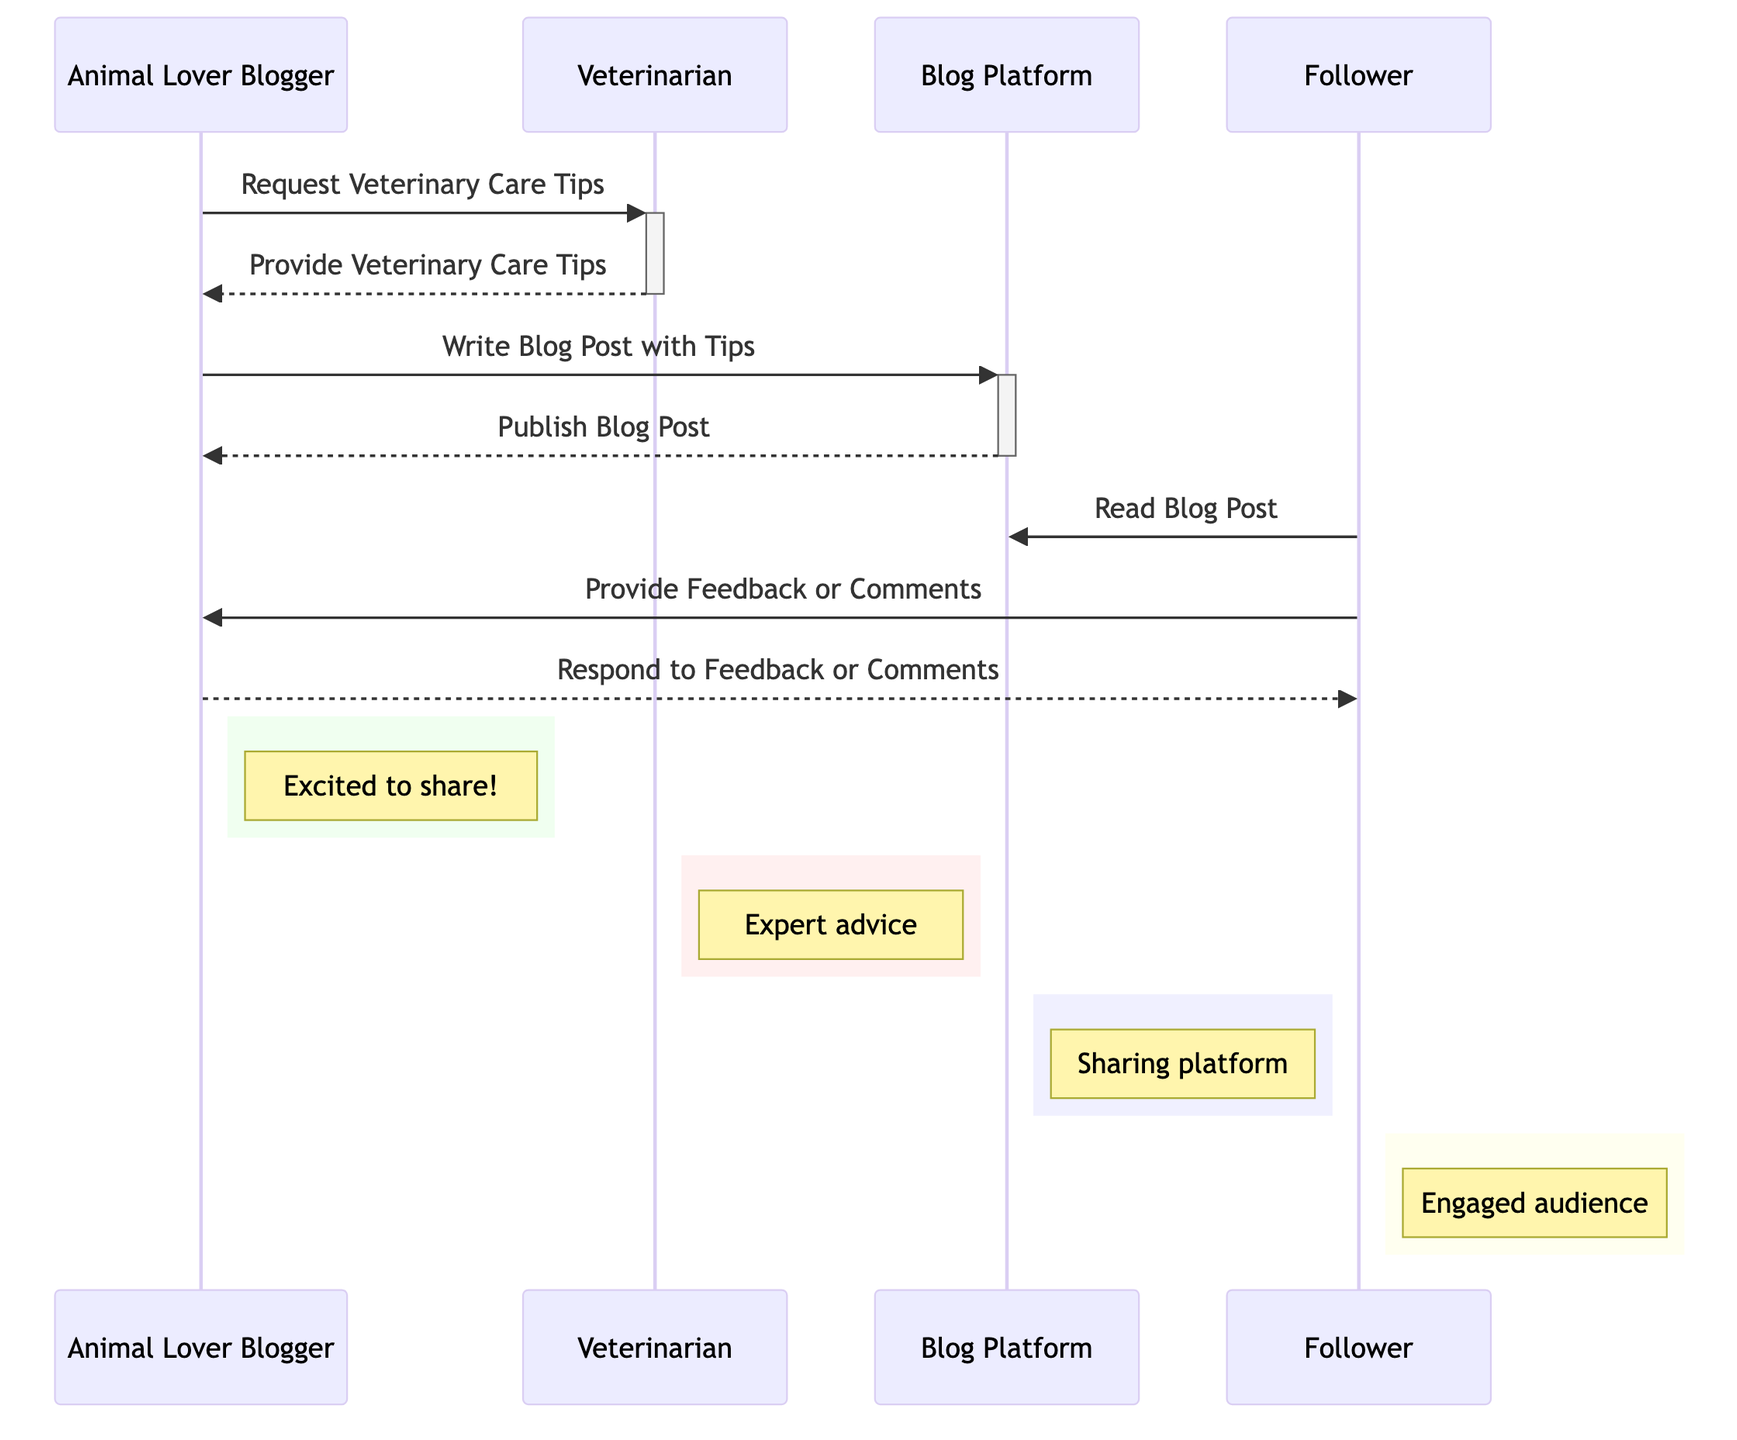What is the first action in the sequence? The first action in the sequence diagram is initiated by the Animal Lover Blogger requesting veterinary care tips from the Veterinarian.
Answer: Request Veterinary Care Tips How many users are represented in the diagram? There are three users represented in the diagram: the Animal Lover Blogger, Veterinarian, and Follower.
Answer: Three users What message does the Veterinarian send to the Animal Lover Blogger? The Veterinarian provides veterinary care tips in response to the Animal Lover Blogger's request.
Answer: Provide Veterinary Care Tips Which entity publishes the blog post? The Blog Platform is responsible for publishing the blog post after it is written by the Animal Lover Blogger.
Answer: Blog Platform What does the Follower do after reading the blog post? After reading the blog post, the Follower provides feedback or comments to the Animal Lover Blogger.
Answer: Provide Feedback or Comments Which entities are involved in exchanging feedback? The Follower provides feedback to the Animal Lover Blogger, who then responds to the feedback. Thus, both the Follower and the Animal Lover Blogger are involved in this exchange.
Answer: Follower and Animal Lover Blogger What role does the Blog Platform play in the sequence? The Blog Platform serves as the medium for the Animal Lover Blogger to publish the blog post, facilitating sharing of the veterinary care tips.
Answer: Sharing platform Who is the expert providing advice in the sequence? The Veterinarian is identified as the expert providing veterinary care tips to the Animal Lover Blogger.
Answer: Veterinarian 